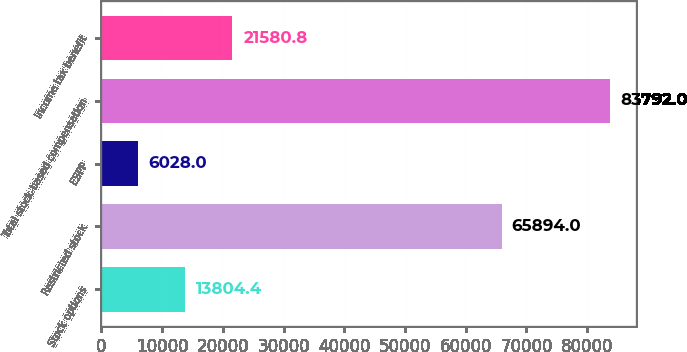<chart> <loc_0><loc_0><loc_500><loc_500><bar_chart><fcel>Stock options<fcel>Restricted stock<fcel>ESPP<fcel>Total stock-based compensation<fcel>Income tax benefit<nl><fcel>13804.4<fcel>65894<fcel>6028<fcel>83792<fcel>21580.8<nl></chart> 